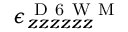Convert formula to latex. <formula><loc_0><loc_0><loc_500><loc_500>\epsilon _ { z z z z z z } ^ { D 6 W M }</formula> 